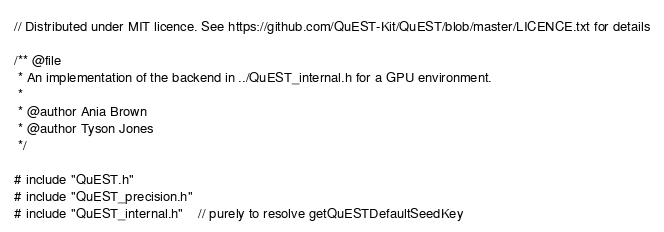<code> <loc_0><loc_0><loc_500><loc_500><_Cuda_>// Distributed under MIT licence. See https://github.com/QuEST-Kit/QuEST/blob/master/LICENCE.txt for details

/** @file
 * An implementation of the backend in ../QuEST_internal.h for a GPU environment.
 *
 * @author Ania Brown 
 * @author Tyson Jones
 */

# include "QuEST.h"
# include "QuEST_precision.h"
# include "QuEST_internal.h"    // purely to resolve getQuESTDefaultSeedKey</code> 